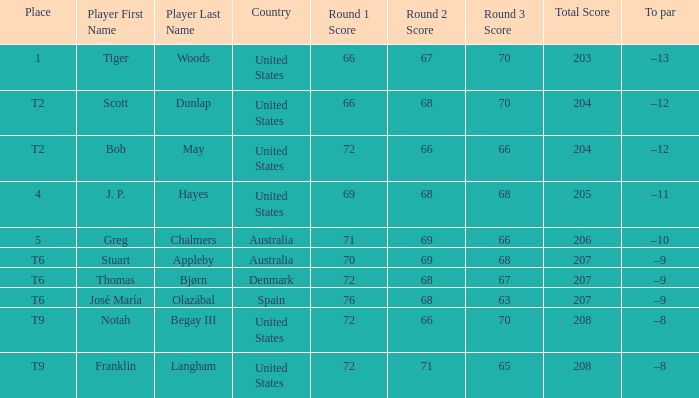From what country does the player thomas bjørn come? Denmark. 